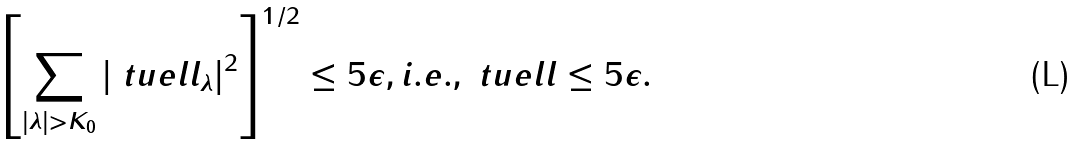<formula> <loc_0><loc_0><loc_500><loc_500>\left [ \sum _ { | \lambda | > K _ { 0 } } | \ t u e l l _ { \lambda } | ^ { 2 } \right ] ^ { 1 / 2 } \leq 5 \epsilon , i . e . , \| \ t u e l l \| \leq 5 \epsilon .</formula> 